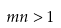<formula> <loc_0><loc_0><loc_500><loc_500>m n > 1</formula> 